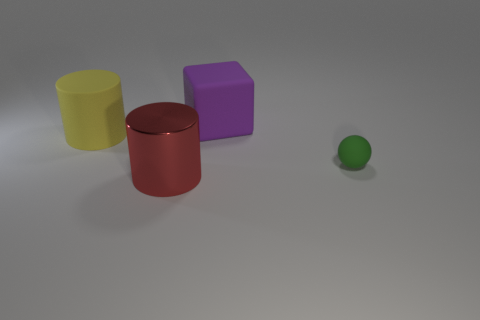Add 3 large purple blocks. How many objects exist? 7 Subtract all cubes. How many objects are left? 3 Add 3 large objects. How many large objects exist? 6 Subtract 0 blue cylinders. How many objects are left? 4 Subtract all rubber cylinders. Subtract all large blue matte spheres. How many objects are left? 3 Add 2 small green matte objects. How many small green matte objects are left? 3 